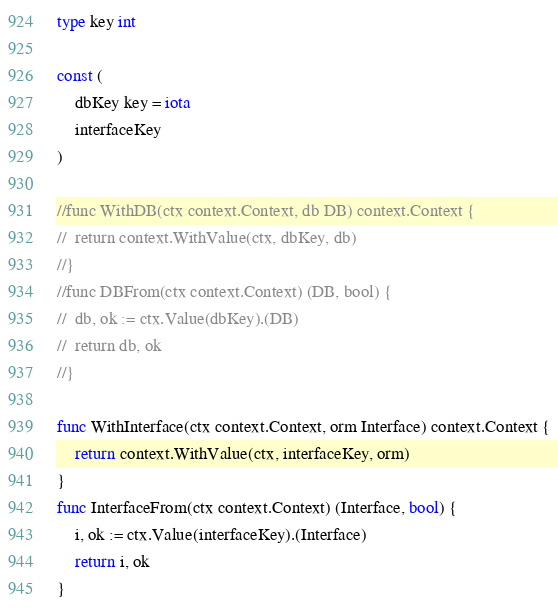Convert code to text. <code><loc_0><loc_0><loc_500><loc_500><_Go_>type key int

const (
	dbKey key = iota
	interfaceKey
)

//func WithDB(ctx context.Context, db DB) context.Context {
//	return context.WithValue(ctx, dbKey, db)
//}
//func DBFrom(ctx context.Context) (DB, bool) {
//	db, ok := ctx.Value(dbKey).(DB)
//	return db, ok
//}

func WithInterface(ctx context.Context, orm Interface) context.Context {
	return context.WithValue(ctx, interfaceKey, orm)
}
func InterfaceFrom(ctx context.Context) (Interface, bool) {
	i, ok := ctx.Value(interfaceKey).(Interface)
	return i, ok
}
</code> 